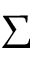Convert formula to latex. <formula><loc_0><loc_0><loc_500><loc_500>\Sigma</formula> 